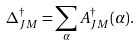Convert formula to latex. <formula><loc_0><loc_0><loc_500><loc_500>\Delta _ { J M } ^ { \dagger } = \sum _ { \alpha } A _ { J M } ^ { \dagger } ( \alpha ) .</formula> 